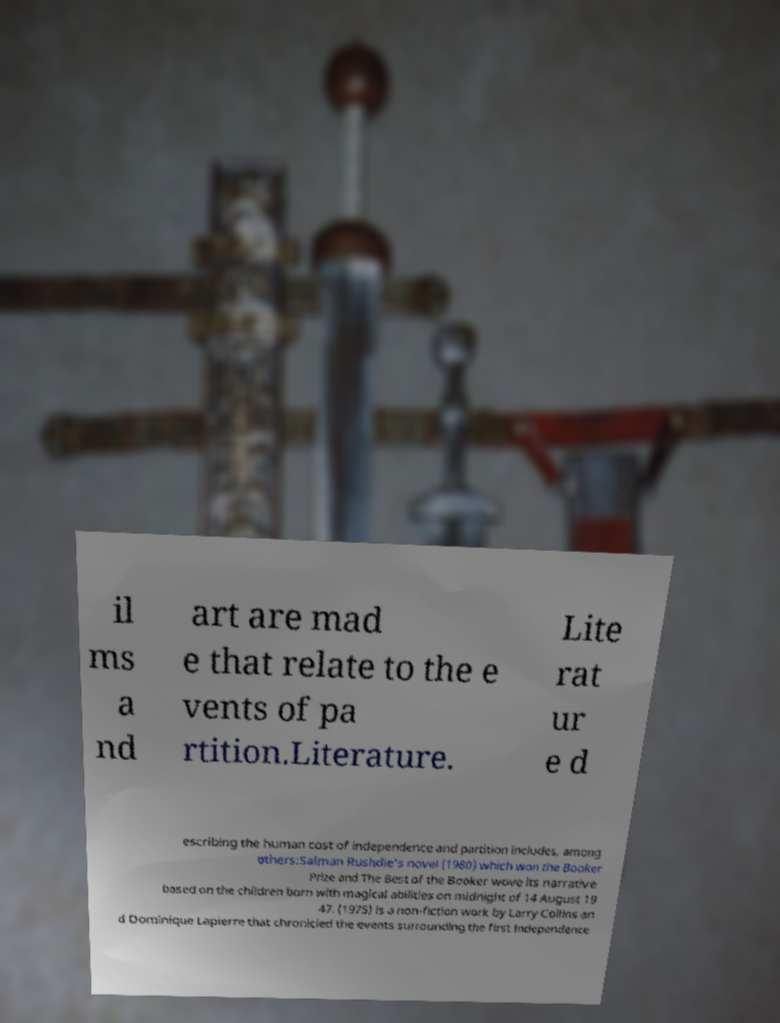Could you assist in decoding the text presented in this image and type it out clearly? il ms a nd art are mad e that relate to the e vents of pa rtition.Literature. Lite rat ur e d escribing the human cost of independence and partition includes, among others:Salman Rushdie's novel (1980) which won the Booker Prize and The Best of the Booker wove its narrative based on the children born with magical abilities on midnight of 14 August 19 47. (1975) is a non-fiction work by Larry Collins an d Dominique Lapierre that chronicled the events surrounding the first Independence 